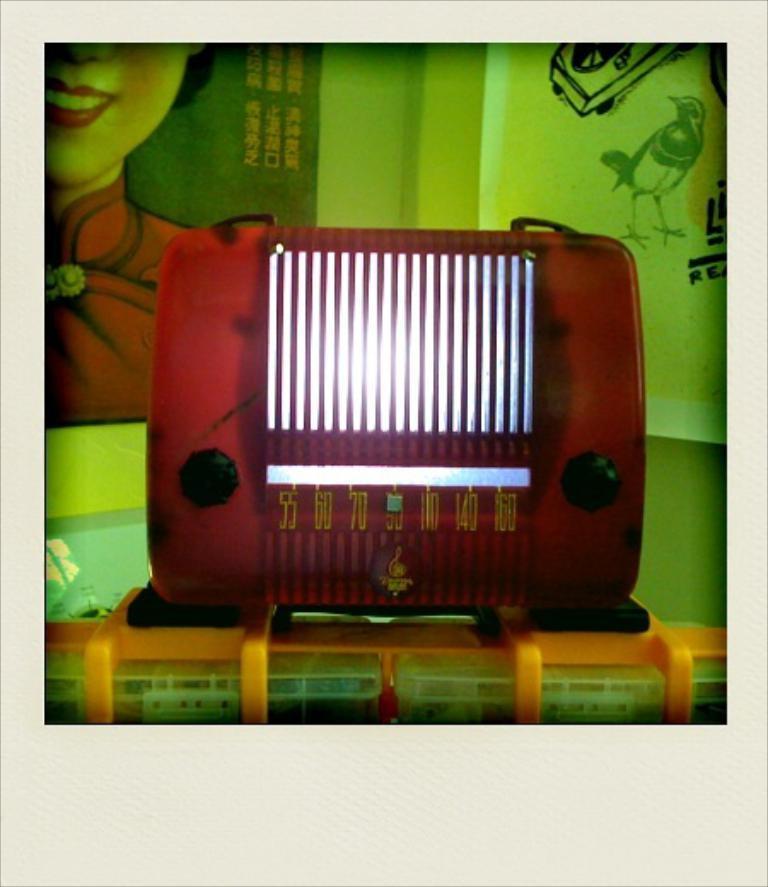How would you summarize this image in a sentence or two? In this image I see a red color object on which there are numbers and I see it is on a orange color thing. In the background I see the poster and I see a woman and I see few words over here and I see the art over here. 